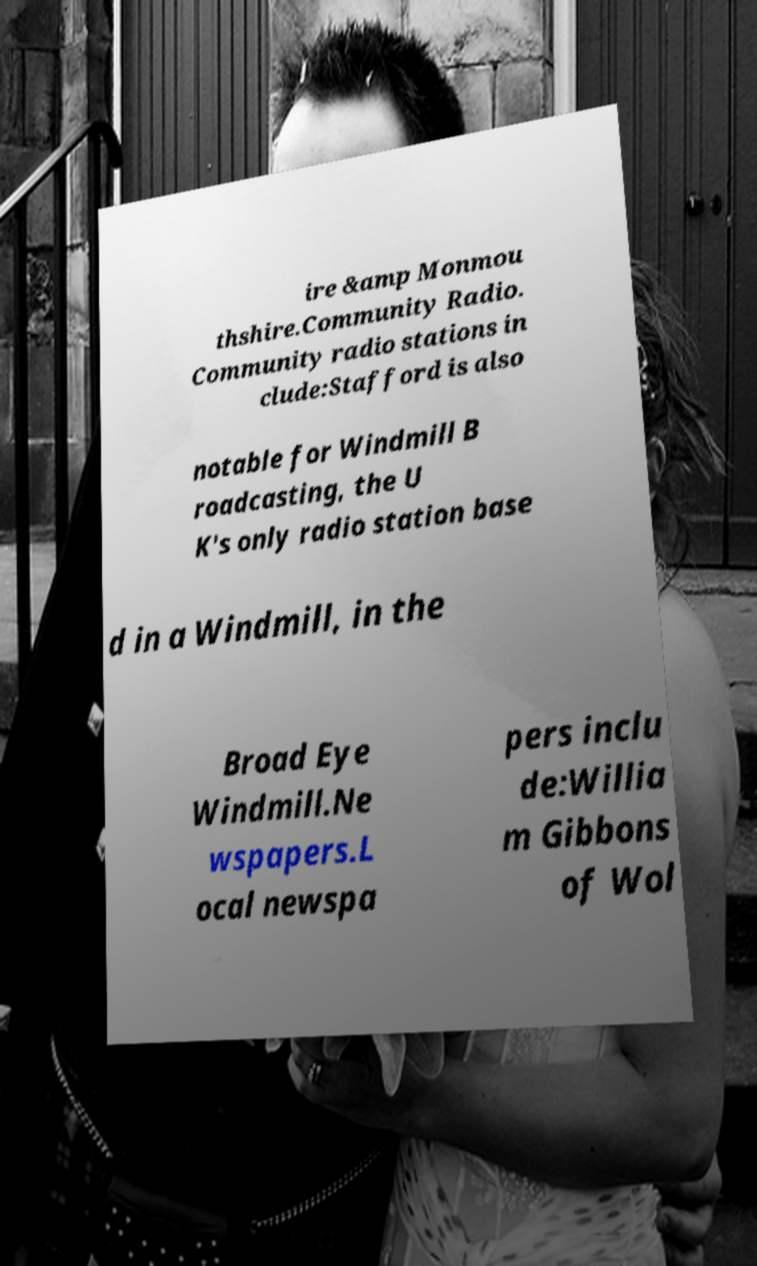There's text embedded in this image that I need extracted. Can you transcribe it verbatim? ire &amp Monmou thshire.Community Radio. Community radio stations in clude:Stafford is also notable for Windmill B roadcasting, the U K's only radio station base d in a Windmill, in the Broad Eye Windmill.Ne wspapers.L ocal newspa pers inclu de:Willia m Gibbons of Wol 